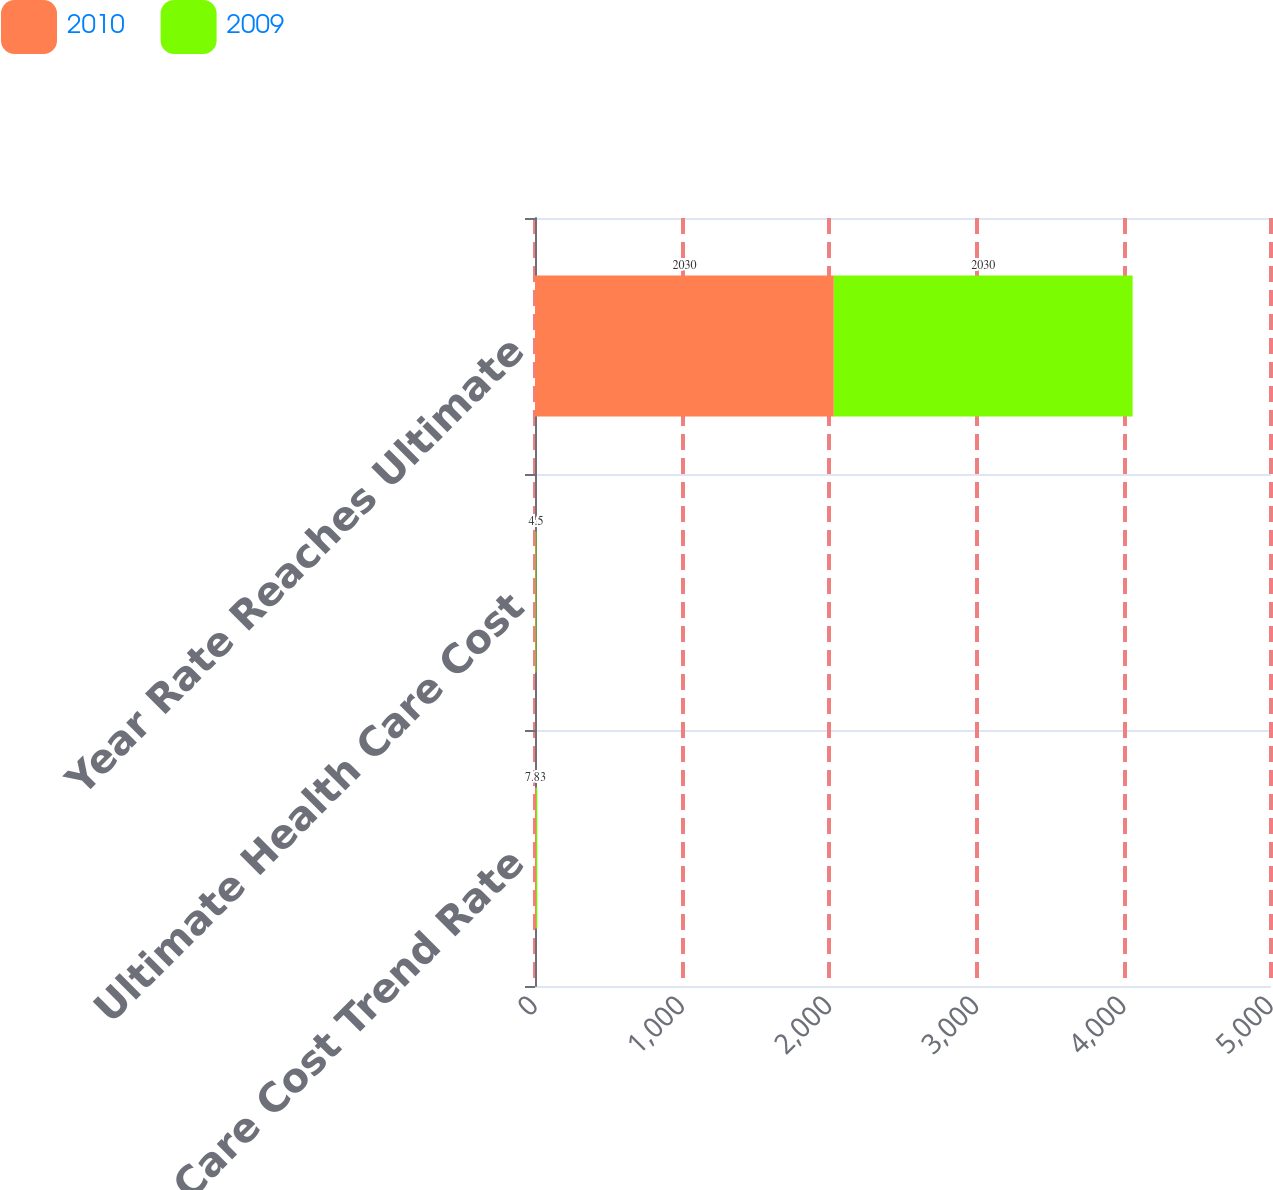Convert chart. <chart><loc_0><loc_0><loc_500><loc_500><stacked_bar_chart><ecel><fcel>Health Care Cost Trend Rate<fcel>Ultimate Health Care Cost<fcel>Year Rate Reaches Ultimate<nl><fcel>2010<fcel>7.83<fcel>4.5<fcel>2030<nl><fcel>2009<fcel>8<fcel>4.5<fcel>2030<nl></chart> 